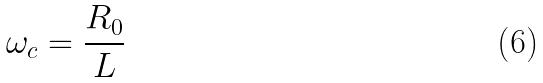Convert formula to latex. <formula><loc_0><loc_0><loc_500><loc_500>\omega _ { c } = \frac { R _ { 0 } } { L }</formula> 